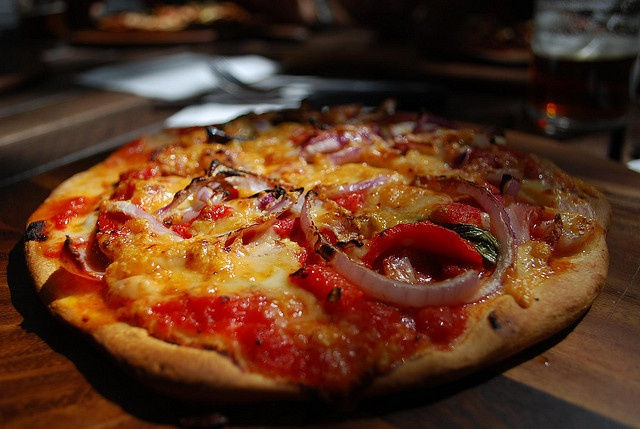Describe the objects in this image and their specific colors. I can see pizza in purple, maroon, black, and brown tones, dining table in purple, black, maroon, and brown tones, dining table in purple, black, maroon, gray, and brown tones, and fork in purple, black, gray, and darkgray tones in this image. 